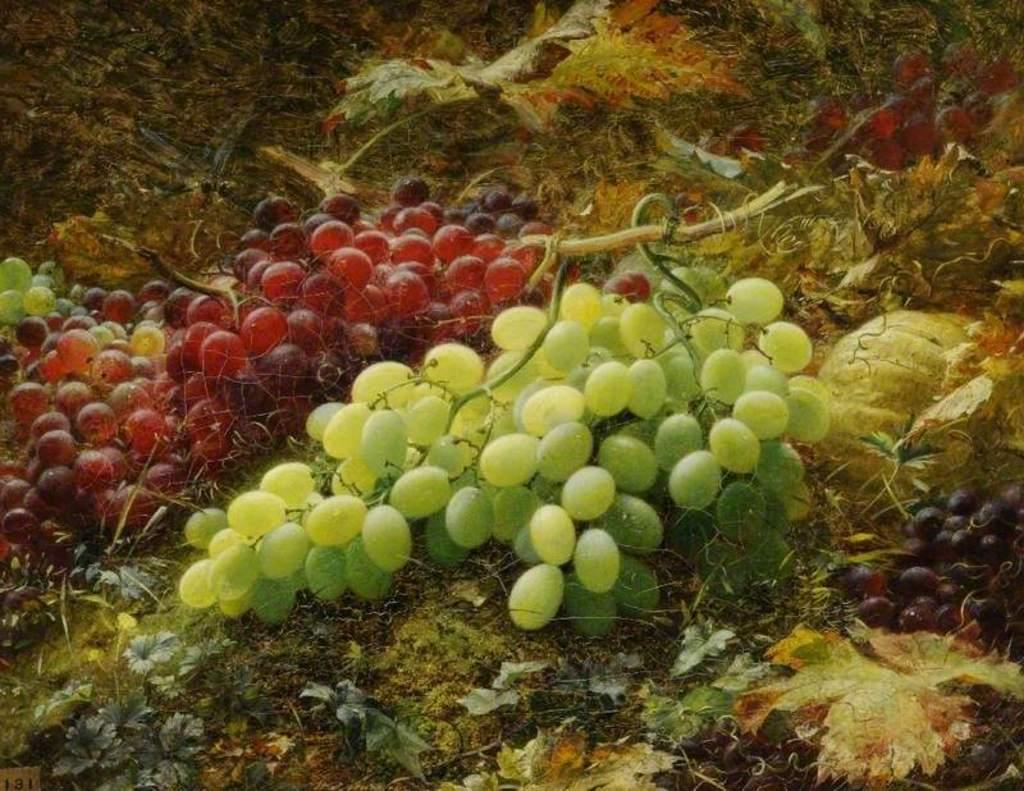What is on the ground in the image? There are grape bunches on the ground in the image. What type of artwork is the image? The image appears to be a painting. Where is the plantation located in the image? There is no plantation present in the image; it only features grape bunches on the ground. What type of winter clothing is visible in the image? There is no winter clothing, such as a mitten, present in the image. 